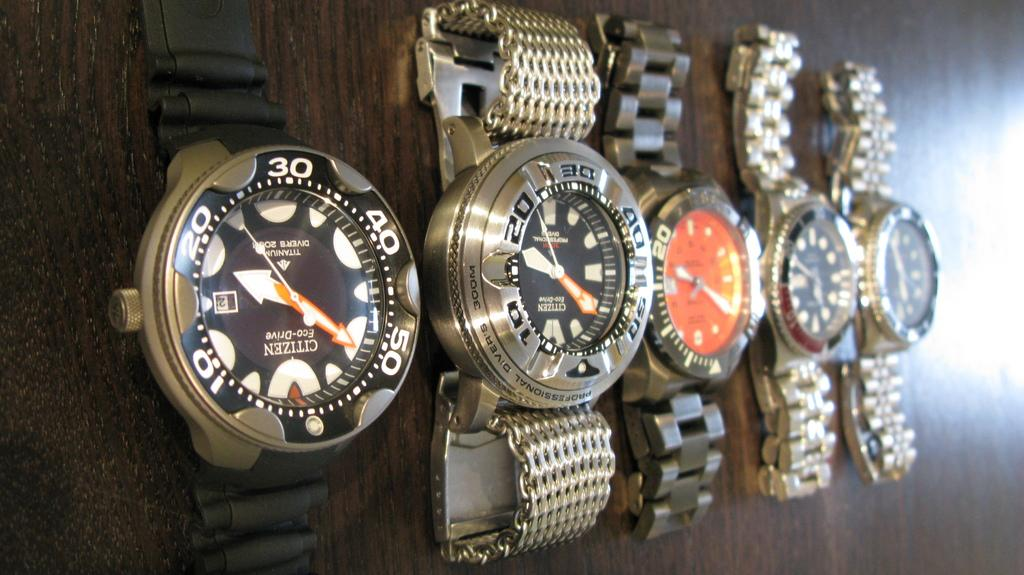<image>
Render a clear and concise summary of the photo. A citizen watch has the brand name upside down on it. 